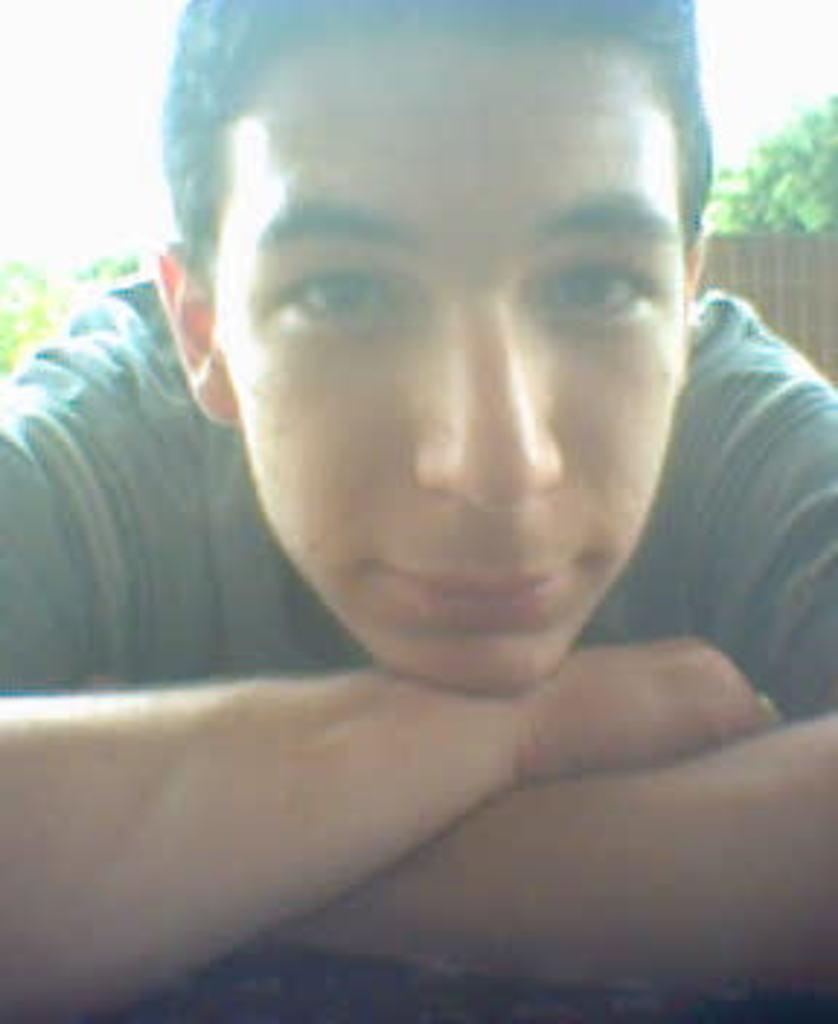Please provide a concise description of this image. In this we can see a person and a wall, also we can see a few trees. 